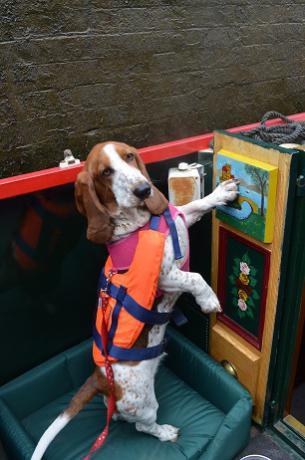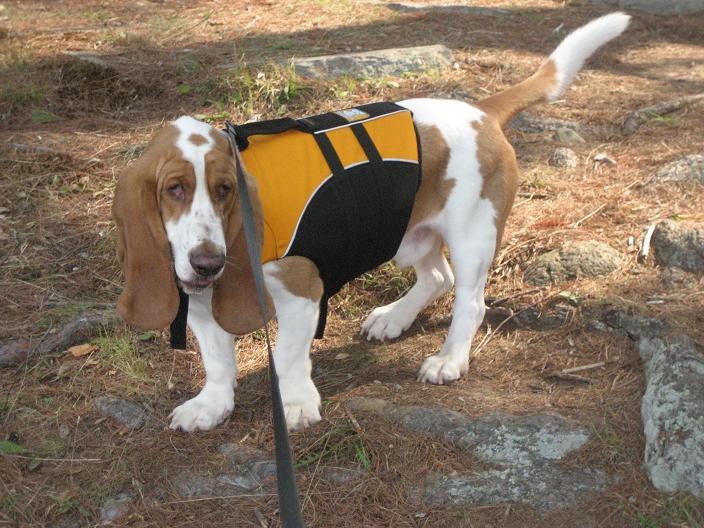The first image is the image on the left, the second image is the image on the right. Analyze the images presented: Is the assertion "In one of the images there is a Basset Hound wearing sunglasses." valid? Answer yes or no. No. 